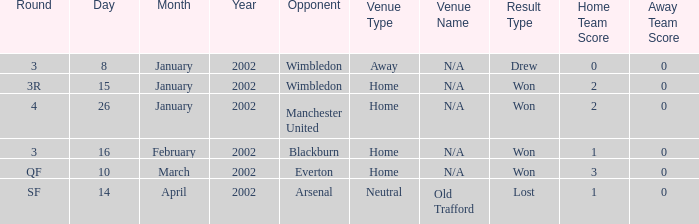What is the Date with a Round with sf? 14 April 2002. 